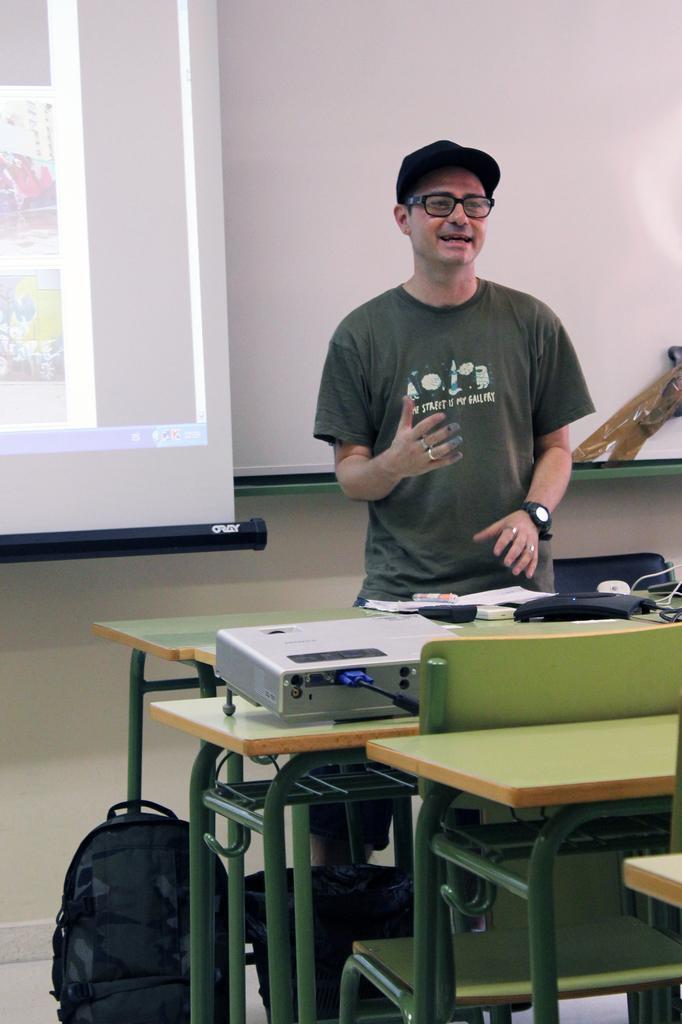How would you summarize this image in a sentence or two? In this image i can see a person wearing a hat, spectates and t shirt standing in front of few benches, On the benches i can see a router, a projector and a bag. In the background i can see a board and a projection screen. 